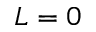<formula> <loc_0><loc_0><loc_500><loc_500>L = 0</formula> 